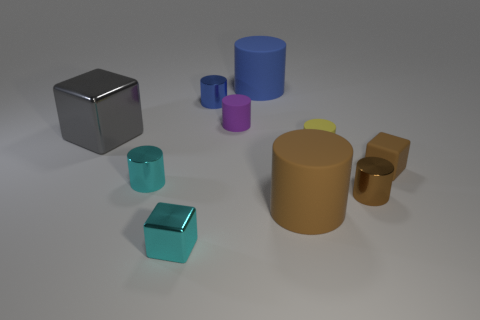Subtract all yellow cylinders. How many cylinders are left? 6 Subtract all big cylinders. How many cylinders are left? 5 Subtract all purple cylinders. Subtract all blue cubes. How many cylinders are left? 6 Subtract all blocks. How many objects are left? 7 Subtract all large gray cubes. Subtract all metal cubes. How many objects are left? 7 Add 7 brown things. How many brown things are left? 10 Add 5 big rubber cylinders. How many big rubber cylinders exist? 7 Subtract 0 green spheres. How many objects are left? 10 